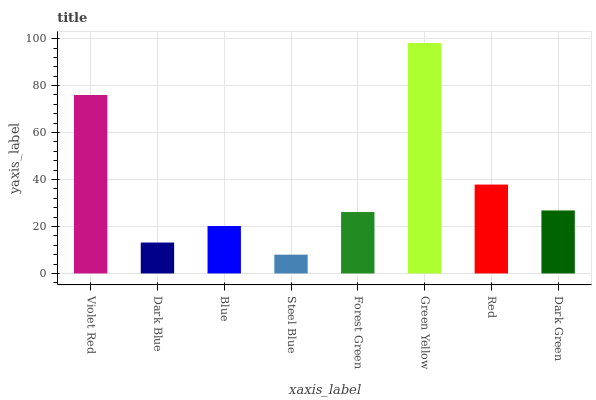Is Dark Blue the minimum?
Answer yes or no. No. Is Dark Blue the maximum?
Answer yes or no. No. Is Violet Red greater than Dark Blue?
Answer yes or no. Yes. Is Dark Blue less than Violet Red?
Answer yes or no. Yes. Is Dark Blue greater than Violet Red?
Answer yes or no. No. Is Violet Red less than Dark Blue?
Answer yes or no. No. Is Dark Green the high median?
Answer yes or no. Yes. Is Forest Green the low median?
Answer yes or no. Yes. Is Green Yellow the high median?
Answer yes or no. No. Is Green Yellow the low median?
Answer yes or no. No. 